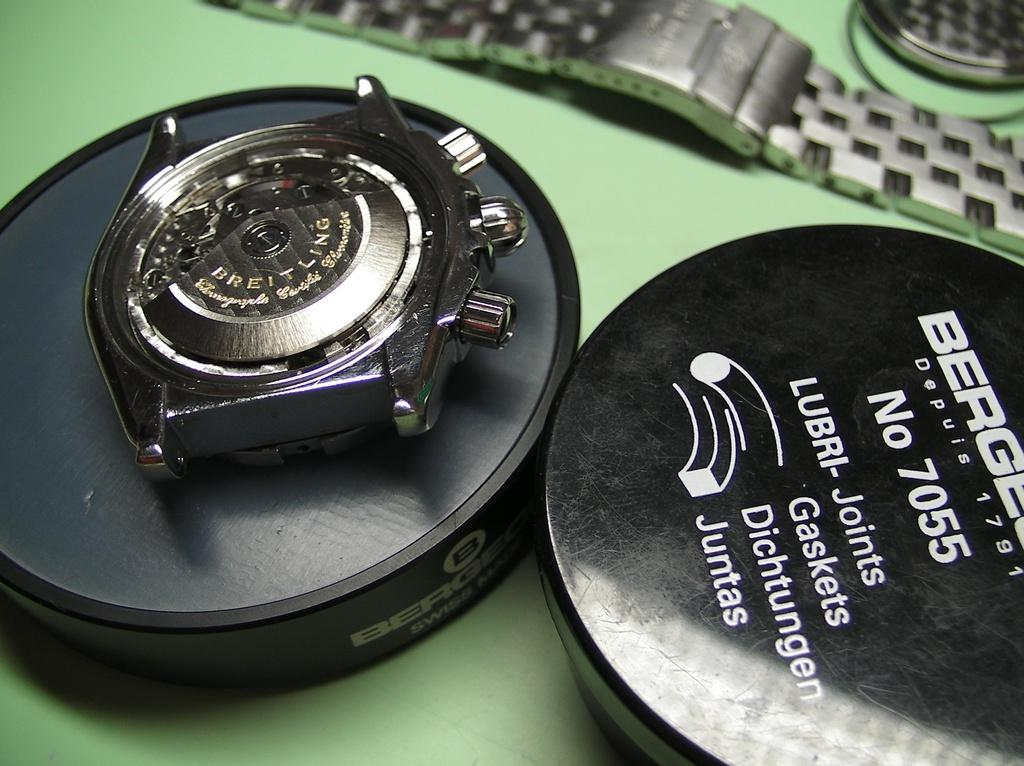Provide a one-sentence caption for the provided image. A close of up of a Breitling watch mechanism and some lubri-joints. 